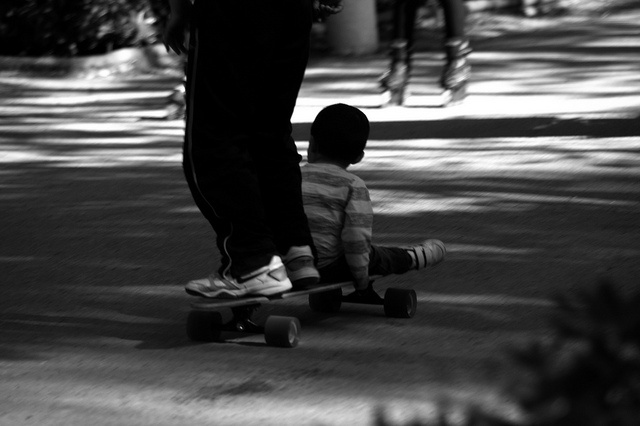Describe the objects in this image and their specific colors. I can see people in black, gray, darkgray, and gainsboro tones, people in black, gray, darkgray, and lightgray tones, skateboard in black, gray, and darkgray tones, and people in black, gray, darkgray, and lightgray tones in this image. 